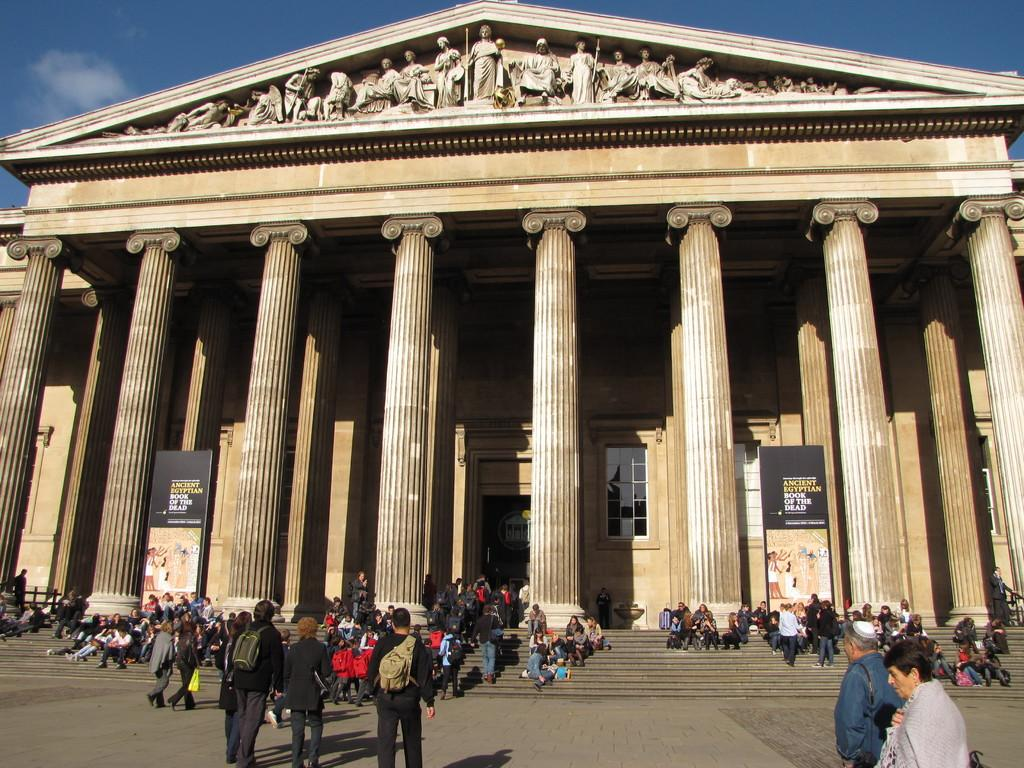Provide a one-sentence caption for the provided image. People visit a large building with a sign that reads Ancient Egyptian Book of the Dead. 